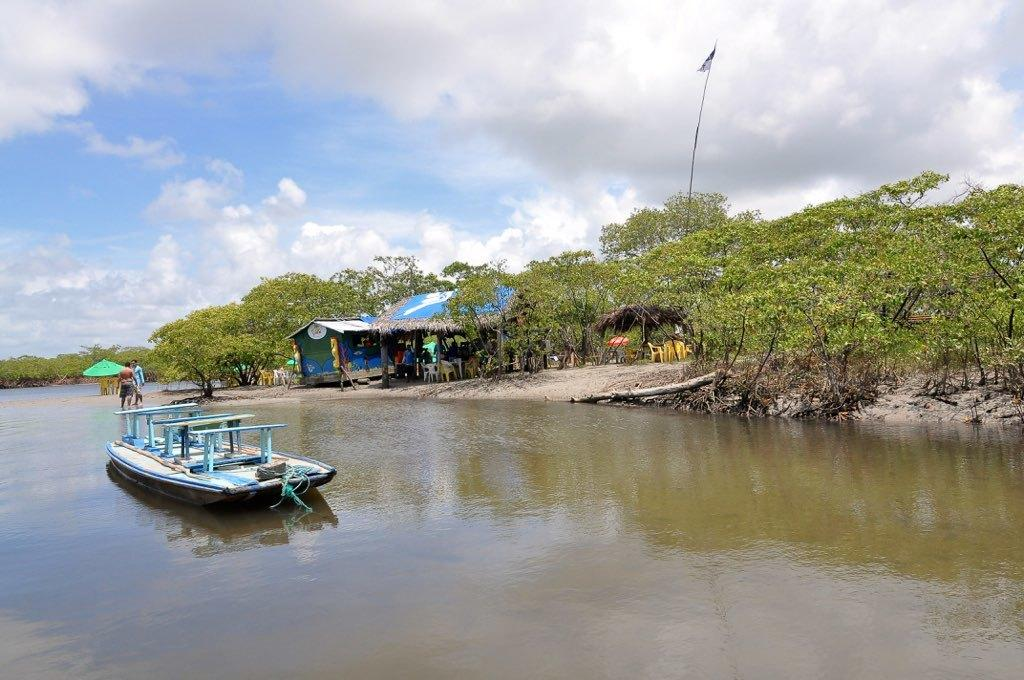What is located above the water in the image? There is a boat above the water in the image. What can be seen on the boat? There are people standing on the boat. What type of structures are present in the image? There are sheds in the image. What type of vegetation is present in the image? Trees are present in the image. What is attached to the flag in the image? There are poles attached to the flag in the image. What is visible in the background of the image? The sky with clouds is visible in the background of the image. What is the taste of the mint in the image? There is no mint present in the image, so it is not possible to determine its taste. 